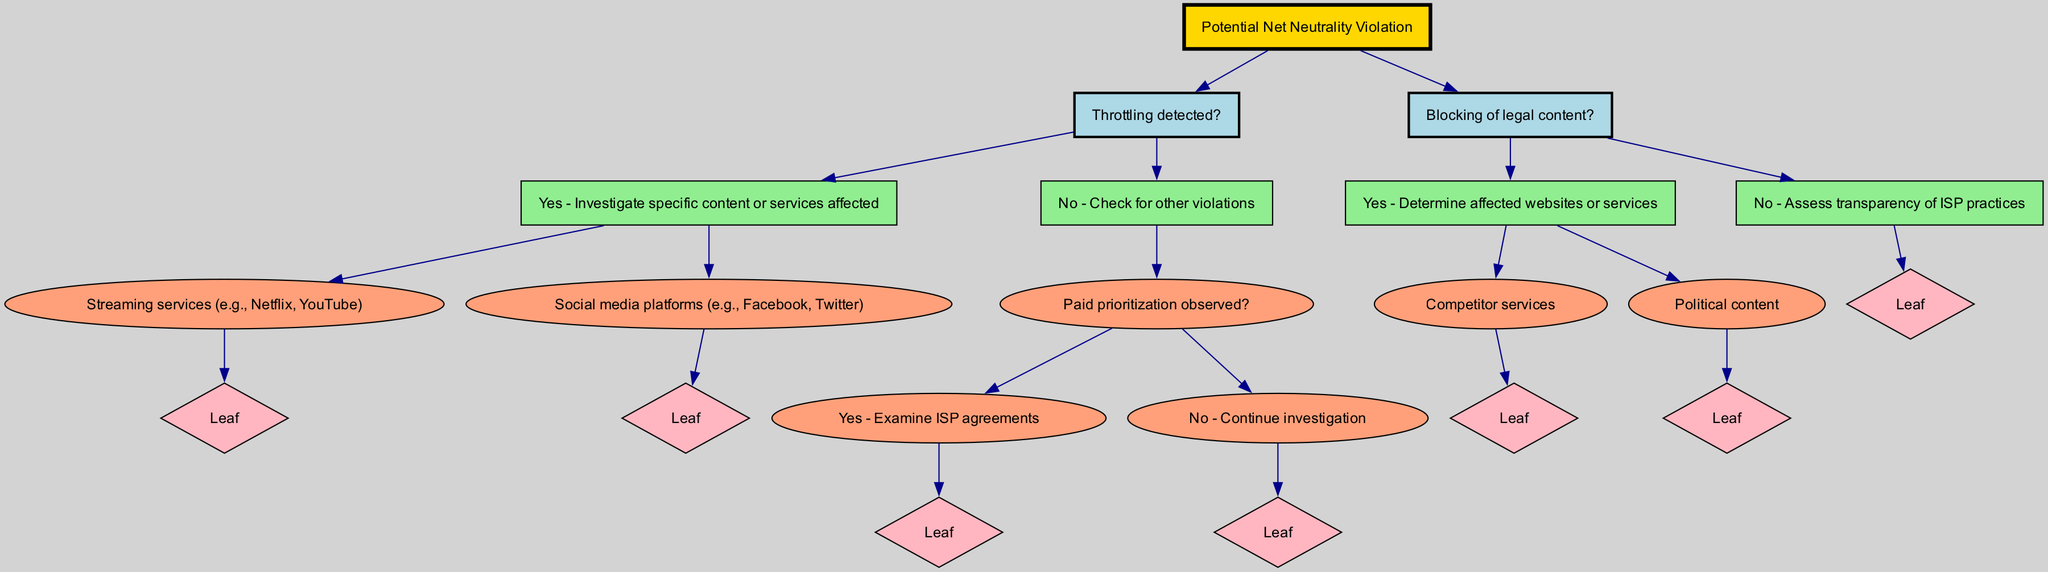What is the root node of the diagram? The root node is the starting point of the decision tree, which indicates the main focus of the diagram. By examining the diagram, we can see that the root node is labeled "Potential Net Neutrality Violation."
Answer: Potential Net Neutrality Violation How many primary nodes are there in the diagram? The primary nodes branch directly from the root node. We can count two main primary nodes labeled "Throttling detected?" and "Blocking of legal content?"
Answer: 2 What does the "Yes" branch of "Throttling detected?" lead to? The "Yes" branch indicates a path for further investigation. It leads to the child nodes that specify different content or services affected by throttling: "Streaming services (e.g., Netflix, YouTube)" and "Social media platforms (e.g., Facebook, Twitter)."
Answer: Investigate specific content or services affected What happens if "Paid prioritization observed?" is answered "No"? If "Paid prioritization observed?" is answered "No," the diagram indicates to "Continue investigation," which suggests further checks may reveal other issues related to net neutrality.
Answer: Continue investigation What are the two leaf nodes under the "Yes" branch of "Blocking of legal content?" For the "Yes" determination of "Blocking of legal content?", the two leaf nodes specify the types of content being blocked: "Competitor services" and "Political content."
Answer: Competitor services, Political content What is the relationship between "Throttling detected?" and "Blocking of legal content?" Both nodes branch out of the root node and represent different potential violations within the broader concept of net neutrality violations; they may lead to different specific investigations but are part of the same overarching structure.
Answer: Sibling nodes Which node requires examination of ISP agreements? The decision leads to examining agreements if "Paid prioritization observed?" is answered with "Yes." This indicates an action to investigate further into the practices of the Internet Service Provider.
Answer: Examine ISP agreements What color represents the root node in the diagram? In the diagram, certain colors are used to differentiate node types. The root node is represented in gold, indicating it is the starting point of the decision tree.
Answer: Gold How many leaf nodes are directly under "Throttling detected?" Under the "Yes" branch of "Throttling detected?", there are two leaf nodes that provide specific types of services affected by throttling: "Streaming services (e.g., Netflix, YouTube)" and "Social media platforms (e.g., Facebook, Twitter)."
Answer: 2 What should be assessed if "Blocking of legal content?" is answered "No"? The answer to "No" in the "Blocking of legal content?" branch indicates that we should assess the transparency of ISP practices, suggesting a different kind of investigation is warranted.
Answer: Assess transparency of ISP practices 